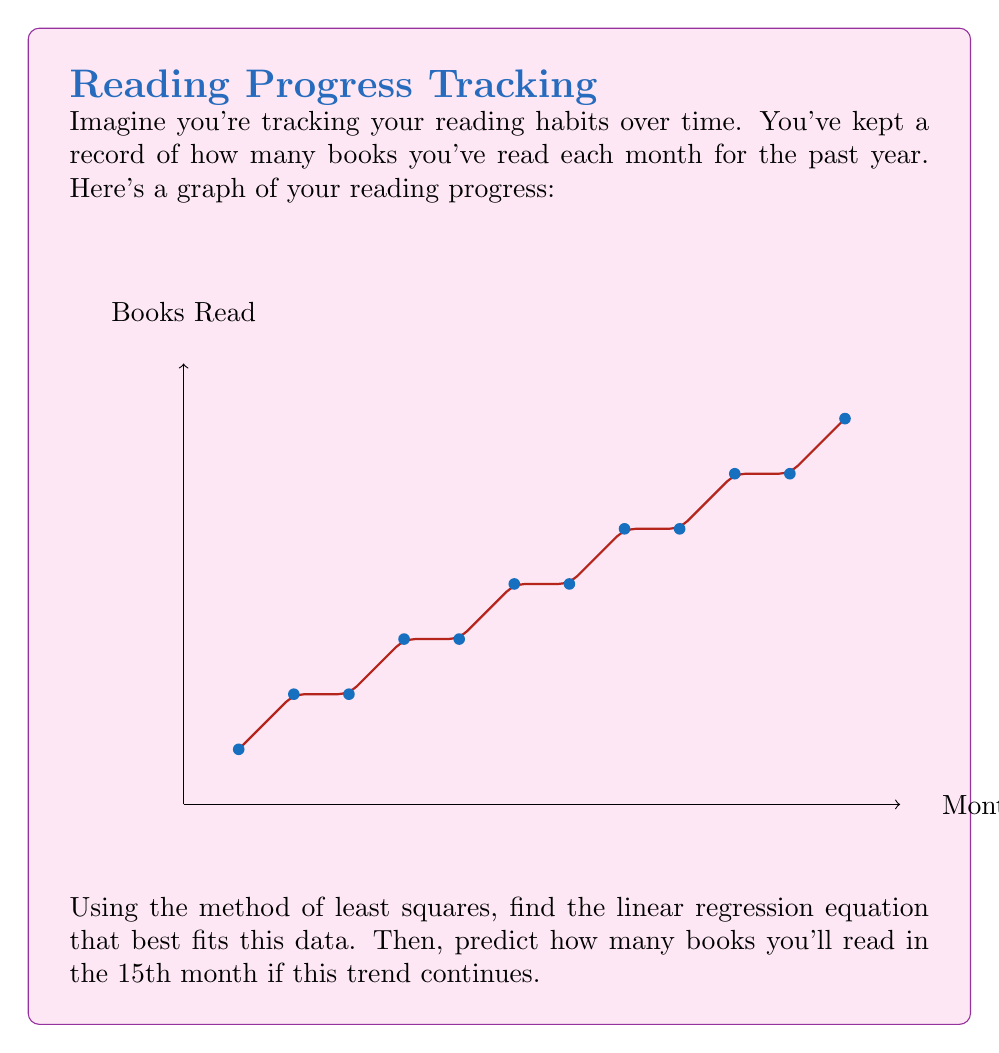Teach me how to tackle this problem. Let's approach this step-by-step:

1) First, we need to calculate the slope (m) and y-intercept (b) for the linear regression equation y = mx + b.

2) For the slope m, we use the formula:

   $$m = \frac{n\sum{xy} - \sum{x}\sum{y}}{n\sum{x^2} - (\sum{x})^2}$$

   where n is the number of data points (12 in this case).

3) For the y-intercept b, we use:

   $$b = \frac{\sum{y} - m\sum{x}}{n}$$

4) Let's calculate the necessary sums:
   
   $\sum{x} = 78$
   $\sum{y} = 48$
   $\sum{xy} = 438$
   $\sum{x^2} = 650$

5) Plugging these into the slope formula:

   $$m = \frac{12(438) - 78(48)}{12(650) - 78^2} = \frac{5256 - 3744}{7800 - 6084} = \frac{1512}{1716} = 0.8809$$

6) Now for the y-intercept:

   $$b = \frac{48 - 0.8809(78)}{12} = 0.5455$$

7) So our linear regression equation is:

   $$y = 0.8809x + 0.5455$$

8) To predict the number of books for the 15th month, we plug in x = 15:

   $$y = 0.8809(15) + 0.5455 = 13.7590$$

9) Since we can't read a fraction of a book, we round to the nearest whole number.
Answer: 14 books 